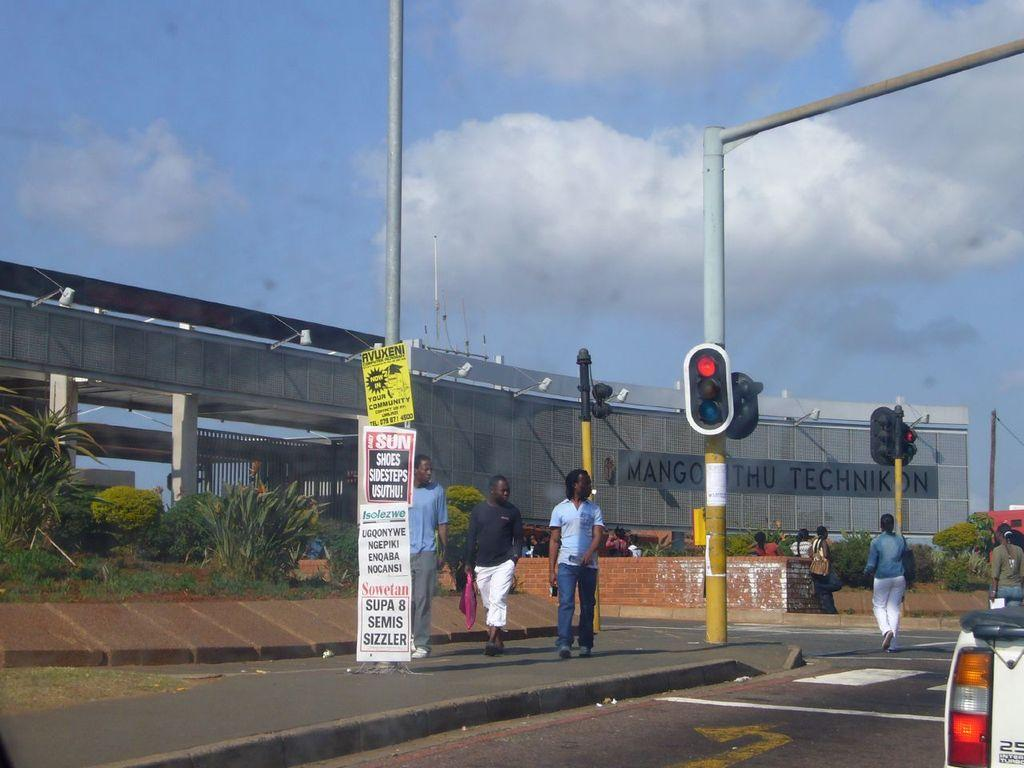<image>
Give a short and clear explanation of the subsequent image. The bottom sign attached to a lamp post ends with the word sizzler. 